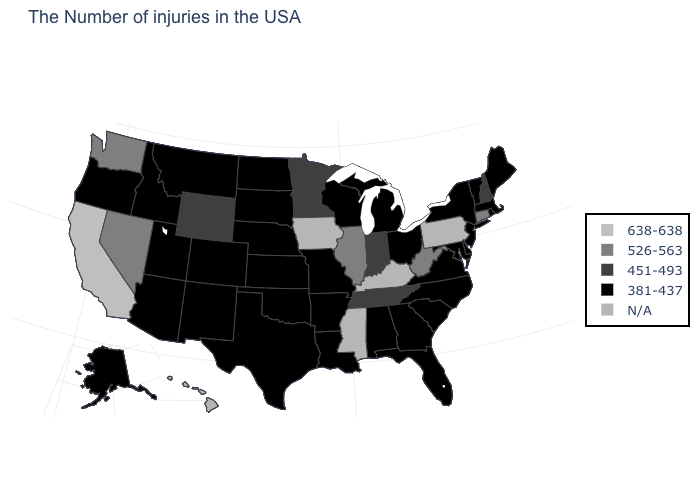Which states hav the highest value in the South?
Short answer required. West Virginia. What is the value of Rhode Island?
Short answer required. 381-437. What is the value of Ohio?
Be succinct. 381-437. Does New Hampshire have the lowest value in the Northeast?
Answer briefly. No. Which states hav the highest value in the Northeast?
Write a very short answer. Connecticut. What is the value of Ohio?
Quick response, please. 381-437. Name the states that have a value in the range 526-563?
Write a very short answer. Connecticut, West Virginia, Illinois, Nevada, Washington. What is the value of New Jersey?
Write a very short answer. 381-437. What is the value of Kansas?
Write a very short answer. 381-437. Name the states that have a value in the range 638-638?
Write a very short answer. California. Does Connecticut have the highest value in the Northeast?
Answer briefly. Yes. Name the states that have a value in the range 381-437?
Concise answer only. Maine, Massachusetts, Rhode Island, Vermont, New York, New Jersey, Delaware, Maryland, Virginia, North Carolina, South Carolina, Ohio, Florida, Georgia, Michigan, Alabama, Wisconsin, Louisiana, Missouri, Arkansas, Kansas, Nebraska, Oklahoma, Texas, South Dakota, North Dakota, Colorado, New Mexico, Utah, Montana, Arizona, Idaho, Oregon, Alaska. Name the states that have a value in the range 381-437?
Write a very short answer. Maine, Massachusetts, Rhode Island, Vermont, New York, New Jersey, Delaware, Maryland, Virginia, North Carolina, South Carolina, Ohio, Florida, Georgia, Michigan, Alabama, Wisconsin, Louisiana, Missouri, Arkansas, Kansas, Nebraska, Oklahoma, Texas, South Dakota, North Dakota, Colorado, New Mexico, Utah, Montana, Arizona, Idaho, Oregon, Alaska. Does Georgia have the highest value in the South?
Short answer required. No. Is the legend a continuous bar?
Concise answer only. No. 